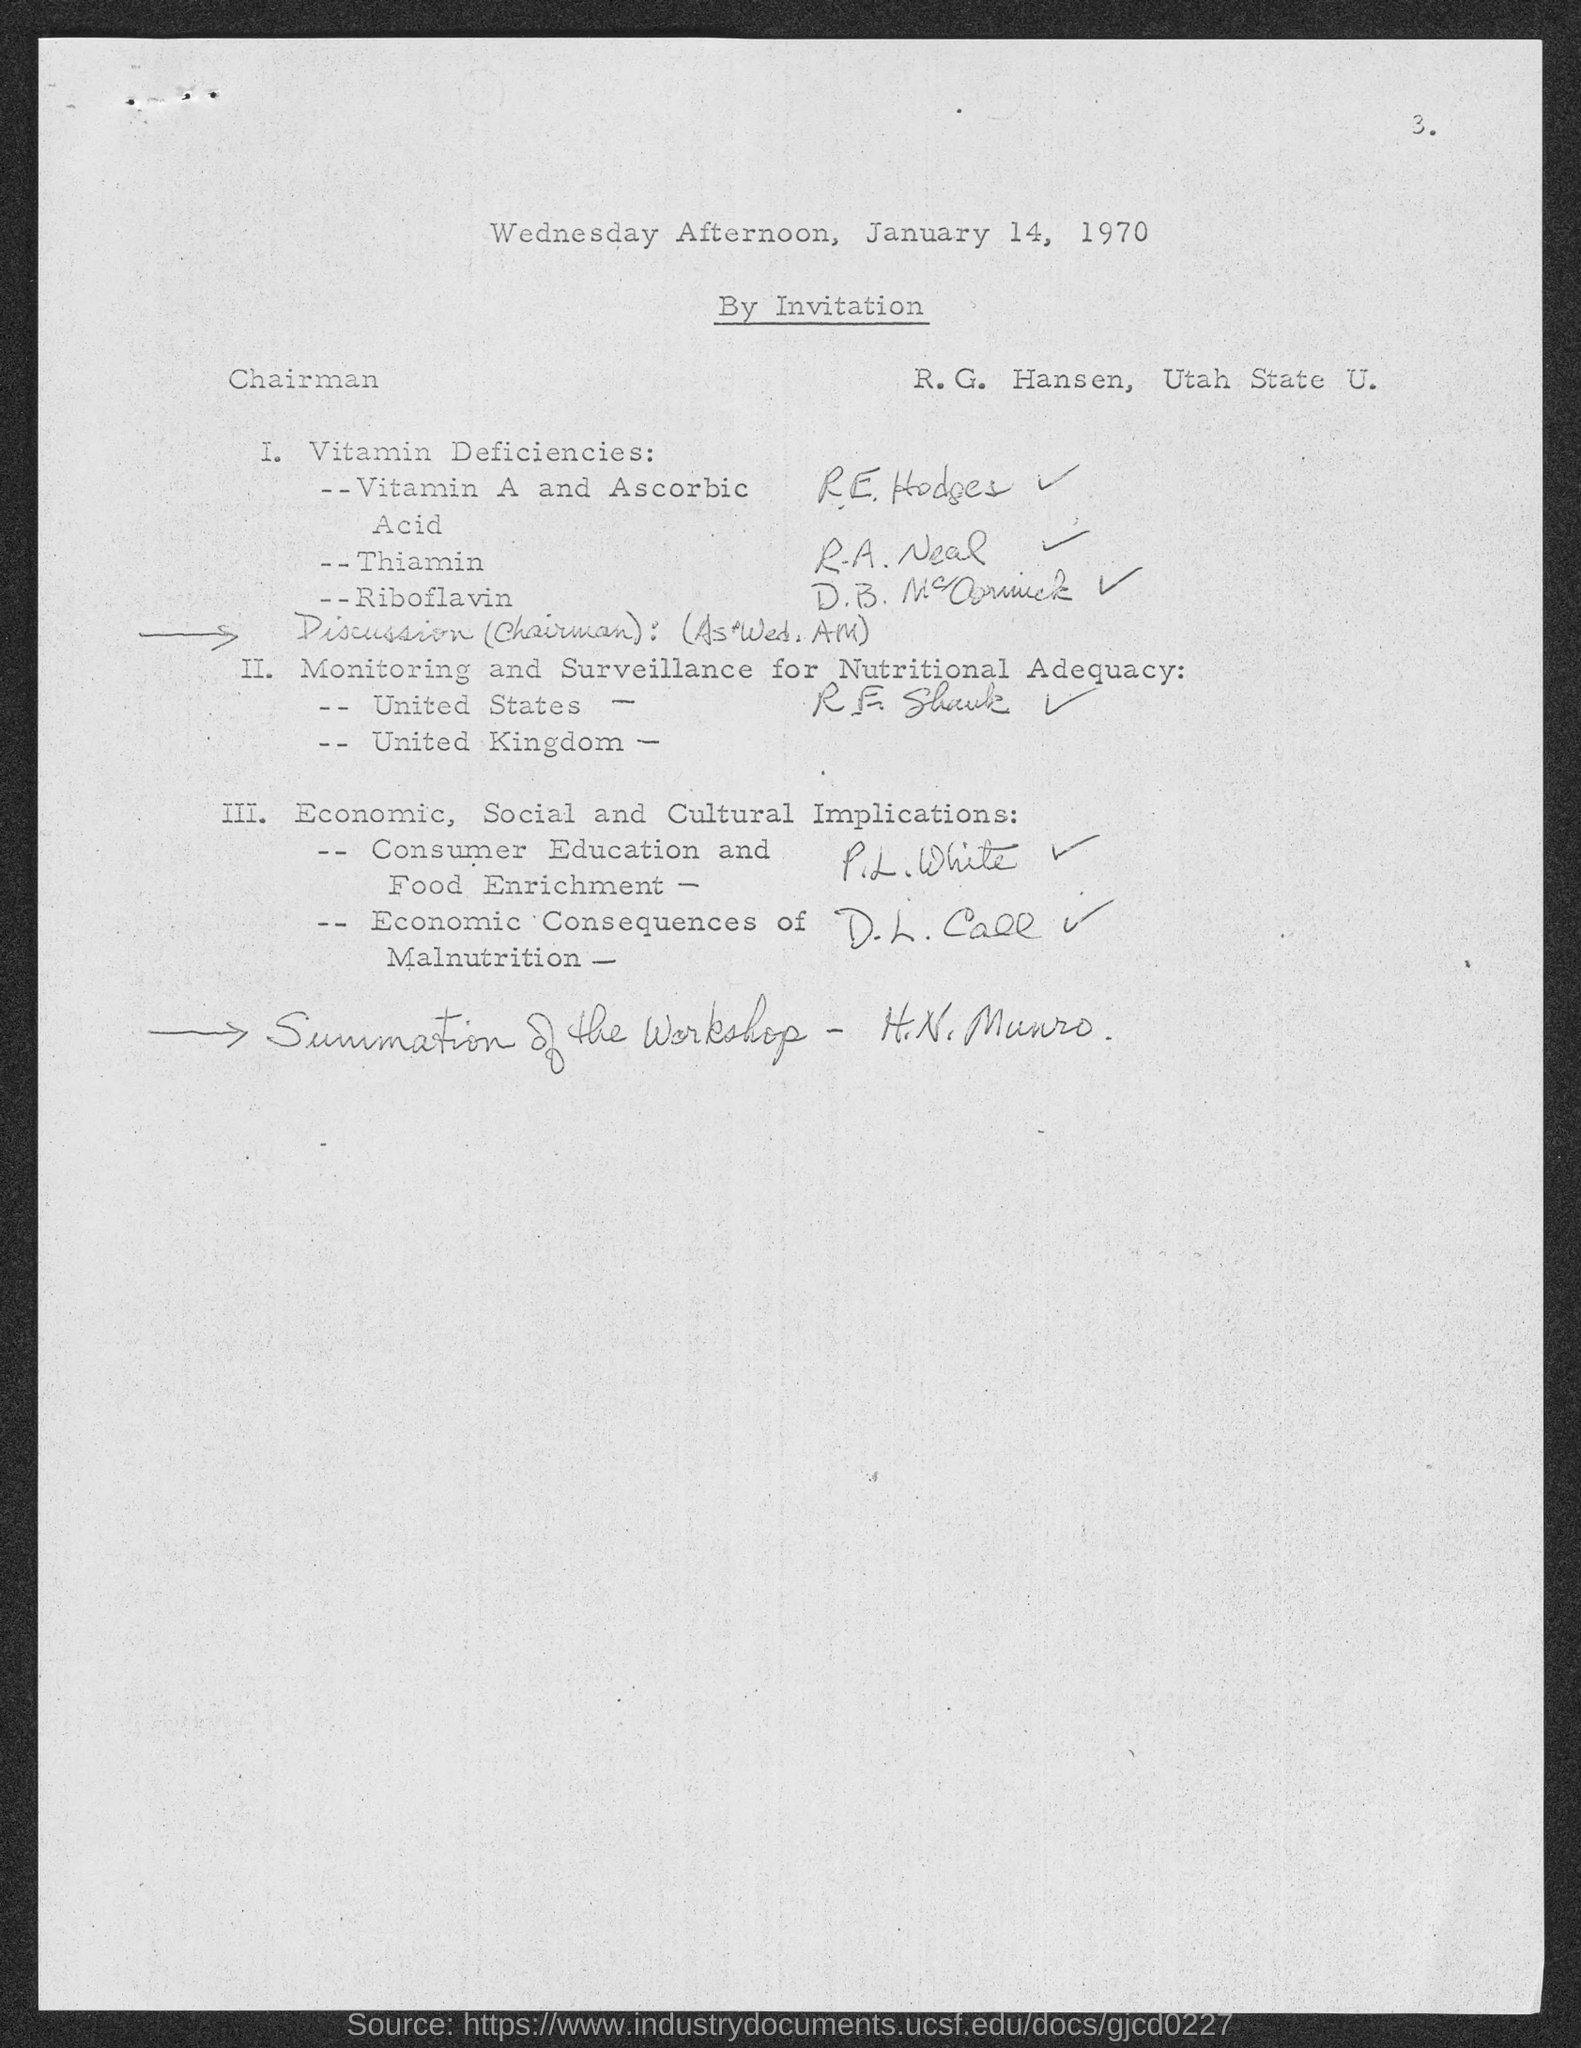What is the date of the document?
Give a very brief answer. January 14, 1970. Who handles Vitamin A and Ascorbic Acid?
Provide a short and direct response. R E Hodger. 